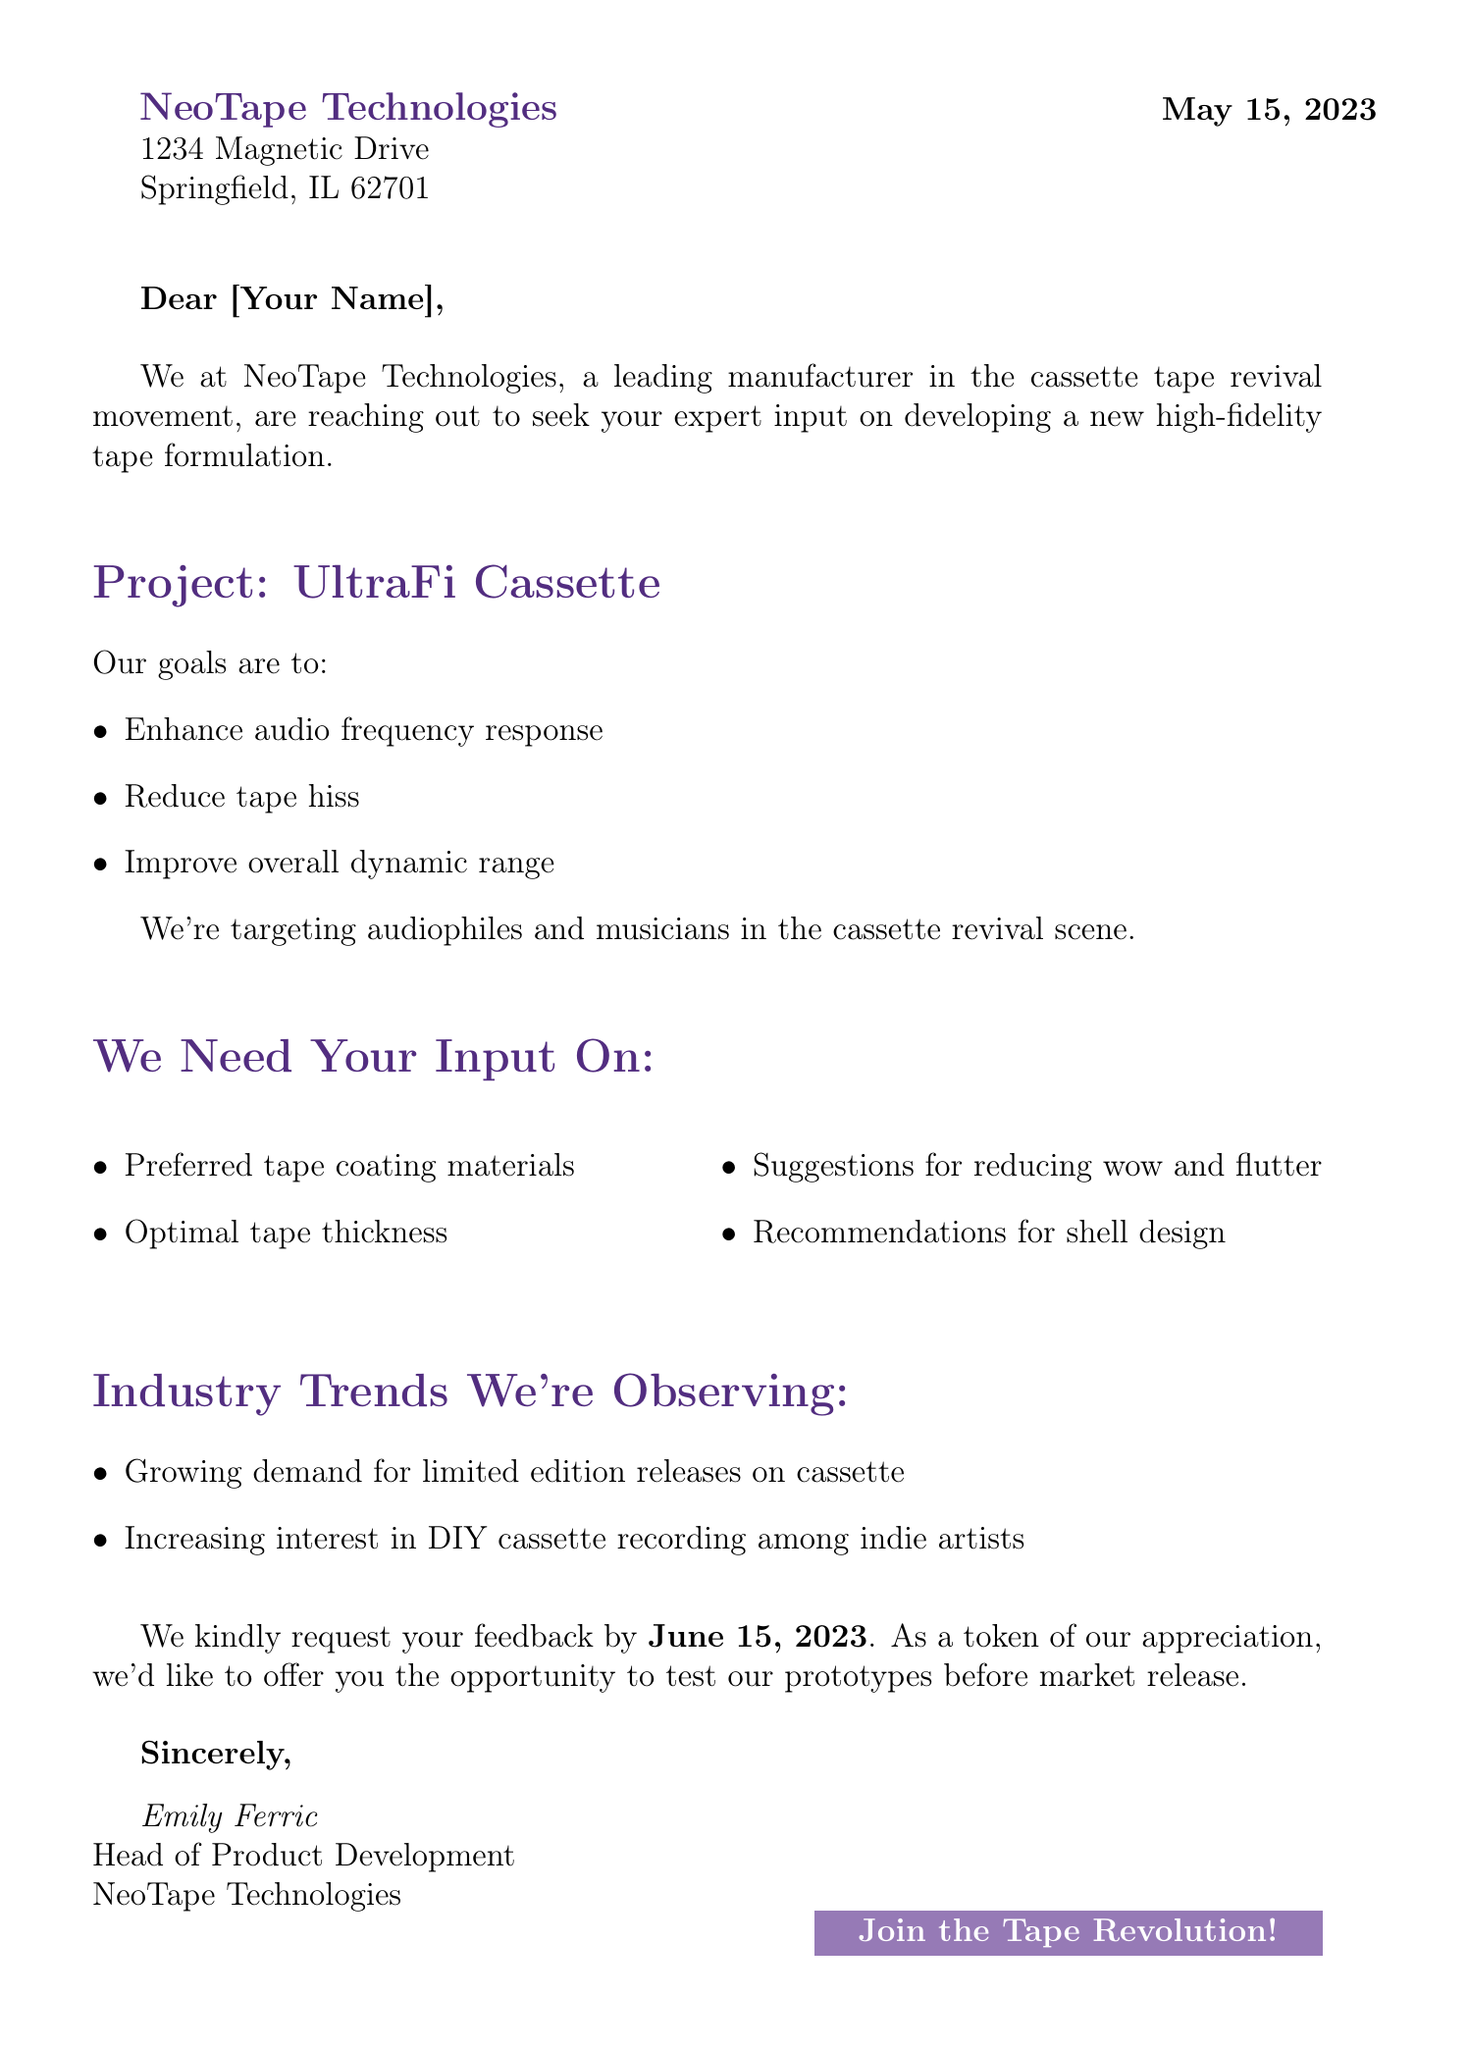what is the company name? The company name is mentioned at the top of the document as the sender, which is NeoTape Technologies.
Answer: NeoTape Technologies what is the date of the letter? The date is specified in the letter's header, indicating when the correspondence was sent, which is May 15, 2023.
Answer: May 15, 2023 who is the head of product development? This person is mentioned in the closing section of the letter, providing their name and title, which is Emily Ferric.
Answer: Emily Ferric what is the project name? The project name is specified in the section that outlines the project, which is UltraFi Cassette.
Answer: UltraFi Cassette what is one goal of the project? The letter lists multiple goals for the project; one of them is to enhance audio frequency response, as stated in the goals section.
Answer: Enhance audio frequency response by when is feedback requested? The document clearly states the deadline for feedback in the closing section, which is June 15, 2023.
Answer: June 15, 2023 what are the preferred coating materials requested for input? This information is found in the section where input is requested, mentioning preferred coating materials.
Answer: chromium dioxide, ferric oxide what audience is targeted for this project? The targeted audience is specified within the project details, focusing on a specific group of music enthusiasts.
Answer: Audiophiles and musicians what is an industry trend mentioned in the letter? The letter discusses industry trends, one of which includes growing demand for limited edition releases on cassette.
Answer: Growing demand for limited edition releases on cassette 